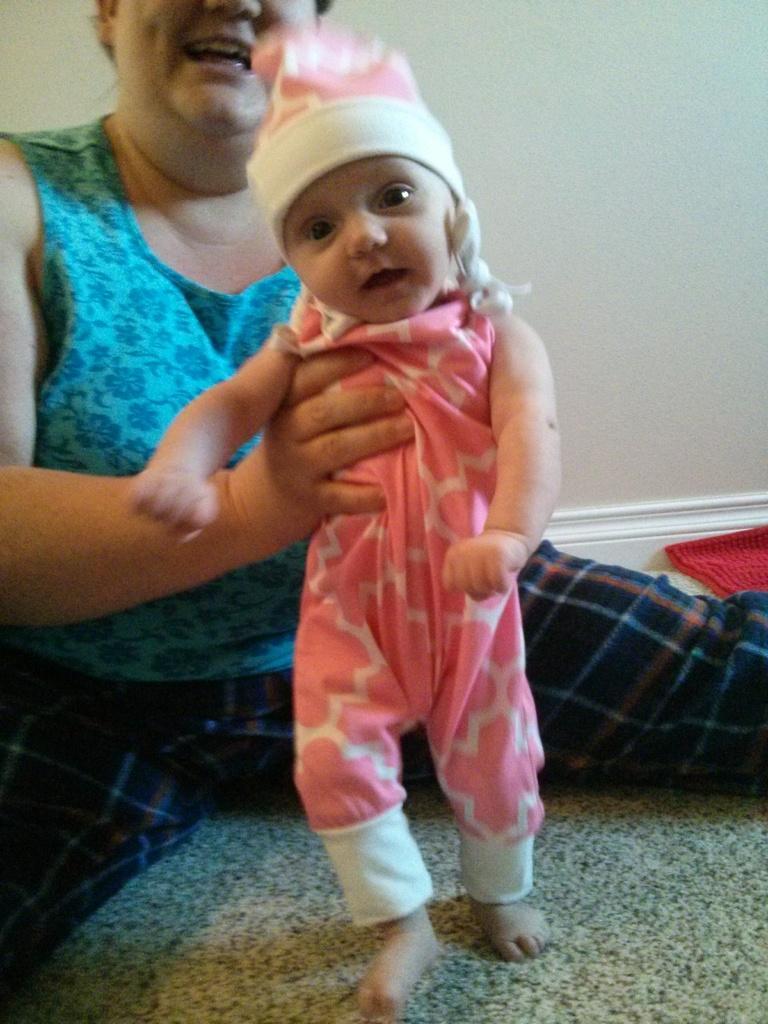In one or two sentences, can you explain what this image depicts? In the picture there is a woman, she is holding a baby with her hands and in the background there is a wall. 